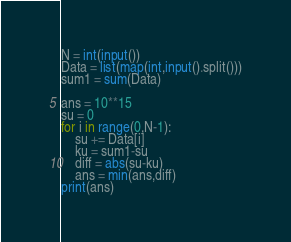Convert code to text. <code><loc_0><loc_0><loc_500><loc_500><_Python_>N = int(input())
Data = list(map(int,input().split()))
sum1 = sum(Data)

ans = 10**15
su = 0
for i in range(0,N-1):
    su += Data[i]
    ku = sum1-su
    diff = abs(su-ku)
    ans = min(ans,diff)
print(ans)
</code> 